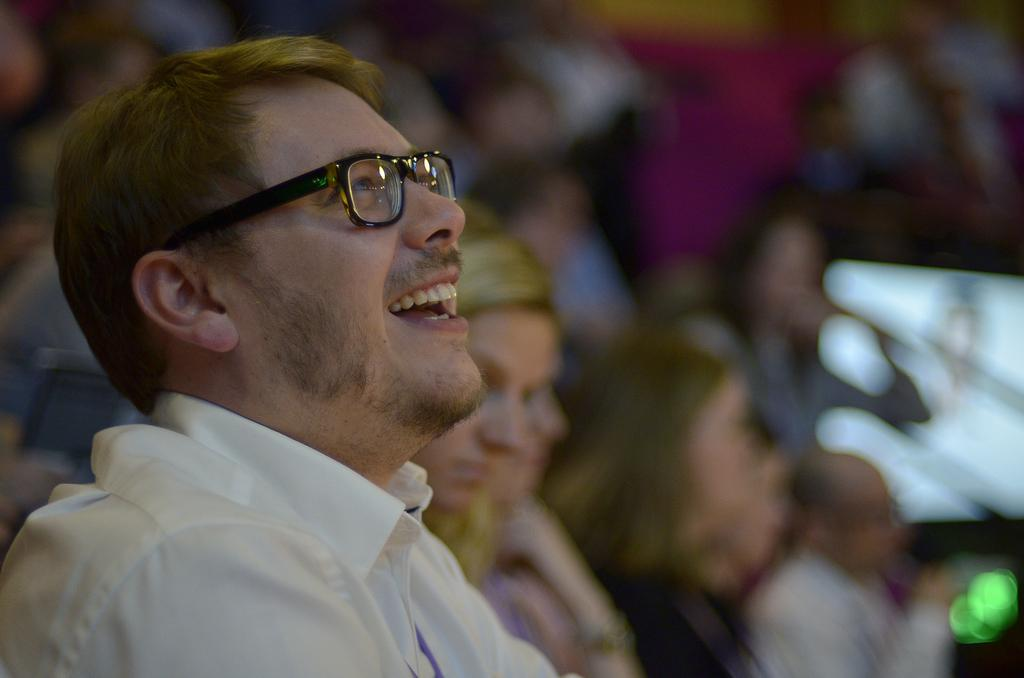How many people are in the image? There is a group of people in the image, but the exact number cannot be determined from the provided facts. What type of location might the image have been taken in? The image may have been taken in a hall, based on the provided facts. Can you determine the time of day the image was taken? The image may have been taken during the night, based on the provided facts. What type of knife is being used by the partner in the image? There is no partner or knife present in the image, so this question cannot be answered. 